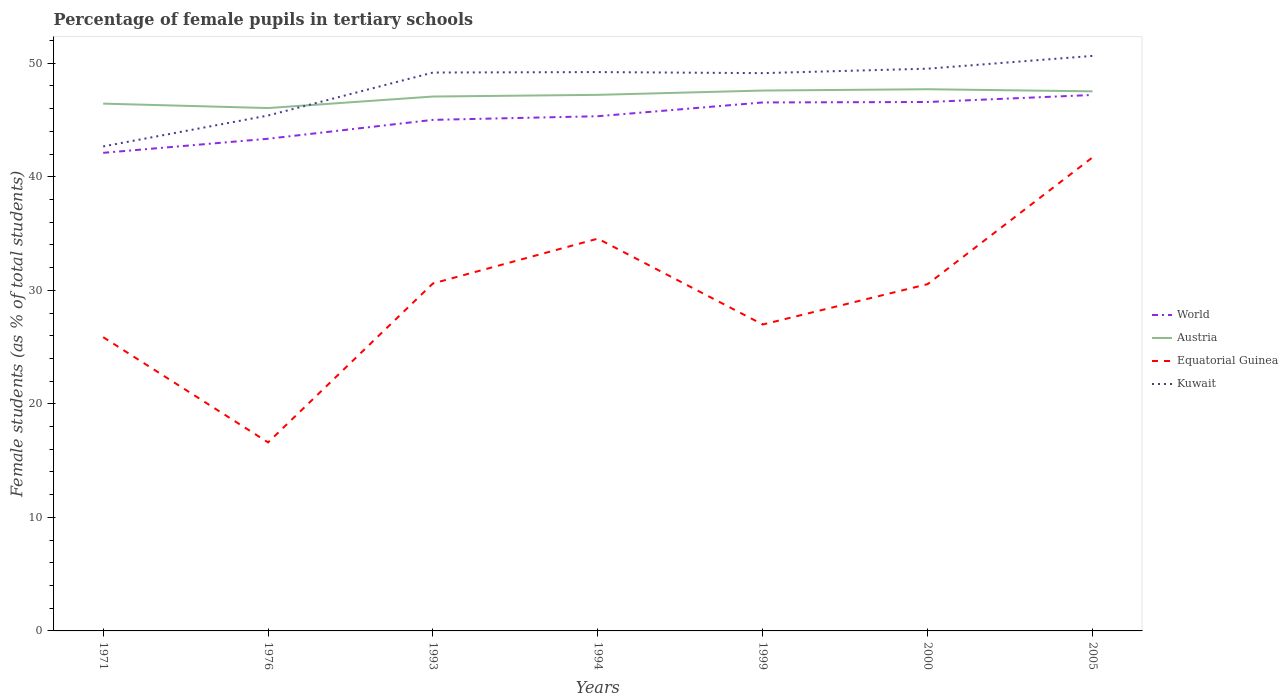Does the line corresponding to Kuwait intersect with the line corresponding to Equatorial Guinea?
Keep it short and to the point. No. Across all years, what is the maximum percentage of female pupils in tertiary schools in World?
Provide a succinct answer. 42.11. In which year was the percentage of female pupils in tertiary schools in Kuwait maximum?
Your answer should be very brief. 1971. What is the total percentage of female pupils in tertiary schools in Kuwait in the graph?
Offer a terse response. -1.47. What is the difference between the highest and the second highest percentage of female pupils in tertiary schools in Kuwait?
Provide a short and direct response. 7.97. What is the difference between the highest and the lowest percentage of female pupils in tertiary schools in World?
Provide a short and direct response. 4. Is the percentage of female pupils in tertiary schools in Austria strictly greater than the percentage of female pupils in tertiary schools in Kuwait over the years?
Keep it short and to the point. No. How many lines are there?
Provide a short and direct response. 4. Are the values on the major ticks of Y-axis written in scientific E-notation?
Make the answer very short. No. Does the graph contain any zero values?
Your answer should be compact. No. Does the graph contain grids?
Ensure brevity in your answer.  No. Where does the legend appear in the graph?
Your response must be concise. Center right. How many legend labels are there?
Provide a succinct answer. 4. What is the title of the graph?
Your answer should be compact. Percentage of female pupils in tertiary schools. Does "Mexico" appear as one of the legend labels in the graph?
Give a very brief answer. No. What is the label or title of the Y-axis?
Give a very brief answer. Female students (as % of total students). What is the Female students (as % of total students) in World in 1971?
Provide a succinct answer. 42.11. What is the Female students (as % of total students) of Austria in 1971?
Provide a short and direct response. 46.44. What is the Female students (as % of total students) of Equatorial Guinea in 1971?
Make the answer very short. 25.87. What is the Female students (as % of total students) of Kuwait in 1971?
Your answer should be compact. 42.67. What is the Female students (as % of total students) of World in 1976?
Ensure brevity in your answer.  43.35. What is the Female students (as % of total students) of Austria in 1976?
Give a very brief answer. 46.05. What is the Female students (as % of total students) in Equatorial Guinea in 1976?
Your answer should be compact. 16.6. What is the Female students (as % of total students) of Kuwait in 1976?
Keep it short and to the point. 45.4. What is the Female students (as % of total students) of World in 1993?
Your response must be concise. 45.01. What is the Female students (as % of total students) of Austria in 1993?
Provide a short and direct response. 47.07. What is the Female students (as % of total students) in Equatorial Guinea in 1993?
Provide a short and direct response. 30.61. What is the Female students (as % of total students) in Kuwait in 1993?
Provide a short and direct response. 49.18. What is the Female students (as % of total students) of World in 1994?
Offer a very short reply. 45.33. What is the Female students (as % of total students) of Austria in 1994?
Provide a short and direct response. 47.22. What is the Female students (as % of total students) of Equatorial Guinea in 1994?
Your answer should be very brief. 34.55. What is the Female students (as % of total students) of Kuwait in 1994?
Provide a succinct answer. 49.22. What is the Female students (as % of total students) of World in 1999?
Offer a terse response. 46.55. What is the Female students (as % of total students) in Austria in 1999?
Ensure brevity in your answer.  47.59. What is the Female students (as % of total students) in Equatorial Guinea in 1999?
Provide a succinct answer. 26.99. What is the Female students (as % of total students) in Kuwait in 1999?
Ensure brevity in your answer.  49.13. What is the Female students (as % of total students) in World in 2000?
Your response must be concise. 46.59. What is the Female students (as % of total students) of Austria in 2000?
Keep it short and to the point. 47.71. What is the Female students (as % of total students) of Equatorial Guinea in 2000?
Your answer should be very brief. 30.54. What is the Female students (as % of total students) of Kuwait in 2000?
Give a very brief answer. 49.52. What is the Female students (as % of total students) in World in 2005?
Offer a terse response. 47.21. What is the Female students (as % of total students) in Austria in 2005?
Make the answer very short. 47.53. What is the Female students (as % of total students) in Equatorial Guinea in 2005?
Keep it short and to the point. 41.71. What is the Female students (as % of total students) in Kuwait in 2005?
Offer a very short reply. 50.65. Across all years, what is the maximum Female students (as % of total students) in World?
Give a very brief answer. 47.21. Across all years, what is the maximum Female students (as % of total students) in Austria?
Offer a very short reply. 47.71. Across all years, what is the maximum Female students (as % of total students) in Equatorial Guinea?
Offer a very short reply. 41.71. Across all years, what is the maximum Female students (as % of total students) of Kuwait?
Keep it short and to the point. 50.65. Across all years, what is the minimum Female students (as % of total students) of World?
Give a very brief answer. 42.11. Across all years, what is the minimum Female students (as % of total students) of Austria?
Your answer should be compact. 46.05. Across all years, what is the minimum Female students (as % of total students) of Equatorial Guinea?
Provide a short and direct response. 16.6. Across all years, what is the minimum Female students (as % of total students) of Kuwait?
Make the answer very short. 42.67. What is the total Female students (as % of total students) in World in the graph?
Your answer should be very brief. 316.14. What is the total Female students (as % of total students) in Austria in the graph?
Ensure brevity in your answer.  329.61. What is the total Female students (as % of total students) of Equatorial Guinea in the graph?
Make the answer very short. 206.88. What is the total Female students (as % of total students) in Kuwait in the graph?
Give a very brief answer. 335.77. What is the difference between the Female students (as % of total students) in World in 1971 and that in 1976?
Make the answer very short. -1.24. What is the difference between the Female students (as % of total students) in Austria in 1971 and that in 1976?
Your answer should be very brief. 0.39. What is the difference between the Female students (as % of total students) of Equatorial Guinea in 1971 and that in 1976?
Give a very brief answer. 9.27. What is the difference between the Female students (as % of total students) of Kuwait in 1971 and that in 1976?
Keep it short and to the point. -2.72. What is the difference between the Female students (as % of total students) in World in 1971 and that in 1993?
Offer a very short reply. -2.9. What is the difference between the Female students (as % of total students) in Austria in 1971 and that in 1993?
Make the answer very short. -0.63. What is the difference between the Female students (as % of total students) in Equatorial Guinea in 1971 and that in 1993?
Ensure brevity in your answer.  -4.73. What is the difference between the Female students (as % of total students) of Kuwait in 1971 and that in 1993?
Offer a very short reply. -6.51. What is the difference between the Female students (as % of total students) in World in 1971 and that in 1994?
Give a very brief answer. -3.22. What is the difference between the Female students (as % of total students) of Austria in 1971 and that in 1994?
Give a very brief answer. -0.77. What is the difference between the Female students (as % of total students) in Equatorial Guinea in 1971 and that in 1994?
Your response must be concise. -8.68. What is the difference between the Female students (as % of total students) of Kuwait in 1971 and that in 1994?
Offer a terse response. -6.55. What is the difference between the Female students (as % of total students) in World in 1971 and that in 1999?
Make the answer very short. -4.44. What is the difference between the Female students (as % of total students) in Austria in 1971 and that in 1999?
Offer a terse response. -1.15. What is the difference between the Female students (as % of total students) in Equatorial Guinea in 1971 and that in 1999?
Provide a succinct answer. -1.12. What is the difference between the Female students (as % of total students) in Kuwait in 1971 and that in 1999?
Provide a succinct answer. -6.46. What is the difference between the Female students (as % of total students) in World in 1971 and that in 2000?
Give a very brief answer. -4.48. What is the difference between the Female students (as % of total students) in Austria in 1971 and that in 2000?
Give a very brief answer. -1.27. What is the difference between the Female students (as % of total students) of Equatorial Guinea in 1971 and that in 2000?
Offer a terse response. -4.67. What is the difference between the Female students (as % of total students) of Kuwait in 1971 and that in 2000?
Keep it short and to the point. -6.85. What is the difference between the Female students (as % of total students) of World in 1971 and that in 2005?
Give a very brief answer. -5.1. What is the difference between the Female students (as % of total students) in Austria in 1971 and that in 2005?
Keep it short and to the point. -1.08. What is the difference between the Female students (as % of total students) of Equatorial Guinea in 1971 and that in 2005?
Your response must be concise. -15.84. What is the difference between the Female students (as % of total students) in Kuwait in 1971 and that in 2005?
Give a very brief answer. -7.97. What is the difference between the Female students (as % of total students) of World in 1976 and that in 1993?
Provide a short and direct response. -1.66. What is the difference between the Female students (as % of total students) in Austria in 1976 and that in 1993?
Offer a very short reply. -1.02. What is the difference between the Female students (as % of total students) of Equatorial Guinea in 1976 and that in 1993?
Give a very brief answer. -14. What is the difference between the Female students (as % of total students) in Kuwait in 1976 and that in 1993?
Provide a succinct answer. -3.79. What is the difference between the Female students (as % of total students) in World in 1976 and that in 1994?
Make the answer very short. -1.98. What is the difference between the Female students (as % of total students) of Austria in 1976 and that in 1994?
Provide a succinct answer. -1.16. What is the difference between the Female students (as % of total students) in Equatorial Guinea in 1976 and that in 1994?
Your response must be concise. -17.95. What is the difference between the Female students (as % of total students) of Kuwait in 1976 and that in 1994?
Keep it short and to the point. -3.83. What is the difference between the Female students (as % of total students) of World in 1976 and that in 1999?
Ensure brevity in your answer.  -3.2. What is the difference between the Female students (as % of total students) of Austria in 1976 and that in 1999?
Offer a terse response. -1.54. What is the difference between the Female students (as % of total students) in Equatorial Guinea in 1976 and that in 1999?
Provide a short and direct response. -10.39. What is the difference between the Female students (as % of total students) in Kuwait in 1976 and that in 1999?
Ensure brevity in your answer.  -3.73. What is the difference between the Female students (as % of total students) in World in 1976 and that in 2000?
Provide a succinct answer. -3.24. What is the difference between the Female students (as % of total students) in Austria in 1976 and that in 2000?
Give a very brief answer. -1.66. What is the difference between the Female students (as % of total students) in Equatorial Guinea in 1976 and that in 2000?
Your answer should be compact. -13.94. What is the difference between the Female students (as % of total students) in Kuwait in 1976 and that in 2000?
Provide a short and direct response. -4.13. What is the difference between the Female students (as % of total students) of World in 1976 and that in 2005?
Ensure brevity in your answer.  -3.86. What is the difference between the Female students (as % of total students) in Austria in 1976 and that in 2005?
Give a very brief answer. -1.47. What is the difference between the Female students (as % of total students) in Equatorial Guinea in 1976 and that in 2005?
Provide a short and direct response. -25.1. What is the difference between the Female students (as % of total students) of Kuwait in 1976 and that in 2005?
Keep it short and to the point. -5.25. What is the difference between the Female students (as % of total students) of World in 1993 and that in 1994?
Your answer should be very brief. -0.32. What is the difference between the Female students (as % of total students) in Austria in 1993 and that in 1994?
Provide a succinct answer. -0.15. What is the difference between the Female students (as % of total students) in Equatorial Guinea in 1993 and that in 1994?
Give a very brief answer. -3.94. What is the difference between the Female students (as % of total students) in Kuwait in 1993 and that in 1994?
Offer a terse response. -0.04. What is the difference between the Female students (as % of total students) in World in 1993 and that in 1999?
Offer a terse response. -1.53. What is the difference between the Female students (as % of total students) in Austria in 1993 and that in 1999?
Ensure brevity in your answer.  -0.53. What is the difference between the Female students (as % of total students) of Equatorial Guinea in 1993 and that in 1999?
Make the answer very short. 3.62. What is the difference between the Female students (as % of total students) in Kuwait in 1993 and that in 1999?
Make the answer very short. 0.05. What is the difference between the Female students (as % of total students) in World in 1993 and that in 2000?
Offer a very short reply. -1.57. What is the difference between the Female students (as % of total students) of Austria in 1993 and that in 2000?
Your answer should be compact. -0.64. What is the difference between the Female students (as % of total students) in Equatorial Guinea in 1993 and that in 2000?
Your response must be concise. 0.06. What is the difference between the Female students (as % of total students) of Kuwait in 1993 and that in 2000?
Keep it short and to the point. -0.34. What is the difference between the Female students (as % of total students) of World in 1993 and that in 2005?
Offer a terse response. -2.19. What is the difference between the Female students (as % of total students) of Austria in 1993 and that in 2005?
Provide a short and direct response. -0.46. What is the difference between the Female students (as % of total students) of Equatorial Guinea in 1993 and that in 2005?
Keep it short and to the point. -11.1. What is the difference between the Female students (as % of total students) in Kuwait in 1993 and that in 2005?
Keep it short and to the point. -1.47. What is the difference between the Female students (as % of total students) in World in 1994 and that in 1999?
Offer a terse response. -1.21. What is the difference between the Female students (as % of total students) in Austria in 1994 and that in 1999?
Keep it short and to the point. -0.38. What is the difference between the Female students (as % of total students) of Equatorial Guinea in 1994 and that in 1999?
Keep it short and to the point. 7.56. What is the difference between the Female students (as % of total students) in Kuwait in 1994 and that in 1999?
Your answer should be very brief. 0.09. What is the difference between the Female students (as % of total students) of World in 1994 and that in 2000?
Offer a terse response. -1.25. What is the difference between the Female students (as % of total students) in Austria in 1994 and that in 2000?
Ensure brevity in your answer.  -0.49. What is the difference between the Female students (as % of total students) in Equatorial Guinea in 1994 and that in 2000?
Your answer should be compact. 4.01. What is the difference between the Female students (as % of total students) in Kuwait in 1994 and that in 2000?
Offer a terse response. -0.3. What is the difference between the Female students (as % of total students) in World in 1994 and that in 2005?
Your answer should be very brief. -1.87. What is the difference between the Female students (as % of total students) of Austria in 1994 and that in 2005?
Your answer should be very brief. -0.31. What is the difference between the Female students (as % of total students) of Equatorial Guinea in 1994 and that in 2005?
Ensure brevity in your answer.  -7.16. What is the difference between the Female students (as % of total students) in Kuwait in 1994 and that in 2005?
Ensure brevity in your answer.  -1.43. What is the difference between the Female students (as % of total students) in World in 1999 and that in 2000?
Offer a terse response. -0.04. What is the difference between the Female students (as % of total students) in Austria in 1999 and that in 2000?
Your response must be concise. -0.12. What is the difference between the Female students (as % of total students) of Equatorial Guinea in 1999 and that in 2000?
Make the answer very short. -3.55. What is the difference between the Female students (as % of total students) in Kuwait in 1999 and that in 2000?
Provide a short and direct response. -0.39. What is the difference between the Female students (as % of total students) in World in 1999 and that in 2005?
Give a very brief answer. -0.66. What is the difference between the Female students (as % of total students) of Austria in 1999 and that in 2005?
Your response must be concise. 0.07. What is the difference between the Female students (as % of total students) in Equatorial Guinea in 1999 and that in 2005?
Your response must be concise. -14.72. What is the difference between the Female students (as % of total students) of Kuwait in 1999 and that in 2005?
Your response must be concise. -1.52. What is the difference between the Female students (as % of total students) in World in 2000 and that in 2005?
Provide a short and direct response. -0.62. What is the difference between the Female students (as % of total students) in Austria in 2000 and that in 2005?
Keep it short and to the point. 0.19. What is the difference between the Female students (as % of total students) of Equatorial Guinea in 2000 and that in 2005?
Ensure brevity in your answer.  -11.17. What is the difference between the Female students (as % of total students) in Kuwait in 2000 and that in 2005?
Offer a very short reply. -1.13. What is the difference between the Female students (as % of total students) in World in 1971 and the Female students (as % of total students) in Austria in 1976?
Provide a short and direct response. -3.94. What is the difference between the Female students (as % of total students) in World in 1971 and the Female students (as % of total students) in Equatorial Guinea in 1976?
Offer a very short reply. 25.51. What is the difference between the Female students (as % of total students) of World in 1971 and the Female students (as % of total students) of Kuwait in 1976?
Your answer should be very brief. -3.29. What is the difference between the Female students (as % of total students) of Austria in 1971 and the Female students (as % of total students) of Equatorial Guinea in 1976?
Your answer should be very brief. 29.84. What is the difference between the Female students (as % of total students) of Austria in 1971 and the Female students (as % of total students) of Kuwait in 1976?
Offer a very short reply. 1.05. What is the difference between the Female students (as % of total students) of Equatorial Guinea in 1971 and the Female students (as % of total students) of Kuwait in 1976?
Ensure brevity in your answer.  -19.52. What is the difference between the Female students (as % of total students) of World in 1971 and the Female students (as % of total students) of Austria in 1993?
Ensure brevity in your answer.  -4.96. What is the difference between the Female students (as % of total students) of World in 1971 and the Female students (as % of total students) of Equatorial Guinea in 1993?
Your answer should be very brief. 11.5. What is the difference between the Female students (as % of total students) in World in 1971 and the Female students (as % of total students) in Kuwait in 1993?
Make the answer very short. -7.07. What is the difference between the Female students (as % of total students) of Austria in 1971 and the Female students (as % of total students) of Equatorial Guinea in 1993?
Offer a very short reply. 15.84. What is the difference between the Female students (as % of total students) of Austria in 1971 and the Female students (as % of total students) of Kuwait in 1993?
Offer a terse response. -2.74. What is the difference between the Female students (as % of total students) of Equatorial Guinea in 1971 and the Female students (as % of total students) of Kuwait in 1993?
Your answer should be compact. -23.31. What is the difference between the Female students (as % of total students) in World in 1971 and the Female students (as % of total students) in Austria in 1994?
Ensure brevity in your answer.  -5.11. What is the difference between the Female students (as % of total students) of World in 1971 and the Female students (as % of total students) of Equatorial Guinea in 1994?
Your answer should be compact. 7.56. What is the difference between the Female students (as % of total students) of World in 1971 and the Female students (as % of total students) of Kuwait in 1994?
Provide a short and direct response. -7.11. What is the difference between the Female students (as % of total students) in Austria in 1971 and the Female students (as % of total students) in Equatorial Guinea in 1994?
Offer a terse response. 11.89. What is the difference between the Female students (as % of total students) in Austria in 1971 and the Female students (as % of total students) in Kuwait in 1994?
Offer a very short reply. -2.78. What is the difference between the Female students (as % of total students) in Equatorial Guinea in 1971 and the Female students (as % of total students) in Kuwait in 1994?
Keep it short and to the point. -23.35. What is the difference between the Female students (as % of total students) of World in 1971 and the Female students (as % of total students) of Austria in 1999?
Make the answer very short. -5.49. What is the difference between the Female students (as % of total students) in World in 1971 and the Female students (as % of total students) in Equatorial Guinea in 1999?
Your response must be concise. 15.12. What is the difference between the Female students (as % of total students) of World in 1971 and the Female students (as % of total students) of Kuwait in 1999?
Give a very brief answer. -7.02. What is the difference between the Female students (as % of total students) in Austria in 1971 and the Female students (as % of total students) in Equatorial Guinea in 1999?
Your answer should be compact. 19.45. What is the difference between the Female students (as % of total students) in Austria in 1971 and the Female students (as % of total students) in Kuwait in 1999?
Offer a terse response. -2.69. What is the difference between the Female students (as % of total students) in Equatorial Guinea in 1971 and the Female students (as % of total students) in Kuwait in 1999?
Your answer should be compact. -23.26. What is the difference between the Female students (as % of total students) in World in 1971 and the Female students (as % of total students) in Austria in 2000?
Your answer should be compact. -5.6. What is the difference between the Female students (as % of total students) in World in 1971 and the Female students (as % of total students) in Equatorial Guinea in 2000?
Provide a short and direct response. 11.57. What is the difference between the Female students (as % of total students) of World in 1971 and the Female students (as % of total students) of Kuwait in 2000?
Provide a short and direct response. -7.41. What is the difference between the Female students (as % of total students) of Austria in 1971 and the Female students (as % of total students) of Equatorial Guinea in 2000?
Your answer should be very brief. 15.9. What is the difference between the Female students (as % of total students) of Austria in 1971 and the Female students (as % of total students) of Kuwait in 2000?
Provide a short and direct response. -3.08. What is the difference between the Female students (as % of total students) of Equatorial Guinea in 1971 and the Female students (as % of total students) of Kuwait in 2000?
Provide a succinct answer. -23.65. What is the difference between the Female students (as % of total students) in World in 1971 and the Female students (as % of total students) in Austria in 2005?
Ensure brevity in your answer.  -5.42. What is the difference between the Female students (as % of total students) of World in 1971 and the Female students (as % of total students) of Equatorial Guinea in 2005?
Your answer should be compact. 0.4. What is the difference between the Female students (as % of total students) of World in 1971 and the Female students (as % of total students) of Kuwait in 2005?
Give a very brief answer. -8.54. What is the difference between the Female students (as % of total students) of Austria in 1971 and the Female students (as % of total students) of Equatorial Guinea in 2005?
Offer a very short reply. 4.74. What is the difference between the Female students (as % of total students) of Austria in 1971 and the Female students (as % of total students) of Kuwait in 2005?
Ensure brevity in your answer.  -4.2. What is the difference between the Female students (as % of total students) of Equatorial Guinea in 1971 and the Female students (as % of total students) of Kuwait in 2005?
Provide a short and direct response. -24.77. What is the difference between the Female students (as % of total students) of World in 1976 and the Female students (as % of total students) of Austria in 1993?
Make the answer very short. -3.72. What is the difference between the Female students (as % of total students) of World in 1976 and the Female students (as % of total students) of Equatorial Guinea in 1993?
Ensure brevity in your answer.  12.74. What is the difference between the Female students (as % of total students) of World in 1976 and the Female students (as % of total students) of Kuwait in 1993?
Offer a very short reply. -5.83. What is the difference between the Female students (as % of total students) of Austria in 1976 and the Female students (as % of total students) of Equatorial Guinea in 1993?
Offer a terse response. 15.45. What is the difference between the Female students (as % of total students) of Austria in 1976 and the Female students (as % of total students) of Kuwait in 1993?
Your response must be concise. -3.13. What is the difference between the Female students (as % of total students) in Equatorial Guinea in 1976 and the Female students (as % of total students) in Kuwait in 1993?
Your response must be concise. -32.58. What is the difference between the Female students (as % of total students) of World in 1976 and the Female students (as % of total students) of Austria in 1994?
Make the answer very short. -3.87. What is the difference between the Female students (as % of total students) of World in 1976 and the Female students (as % of total students) of Equatorial Guinea in 1994?
Offer a terse response. 8.8. What is the difference between the Female students (as % of total students) in World in 1976 and the Female students (as % of total students) in Kuwait in 1994?
Your answer should be very brief. -5.87. What is the difference between the Female students (as % of total students) of Austria in 1976 and the Female students (as % of total students) of Equatorial Guinea in 1994?
Offer a very short reply. 11.5. What is the difference between the Female students (as % of total students) in Austria in 1976 and the Female students (as % of total students) in Kuwait in 1994?
Give a very brief answer. -3.17. What is the difference between the Female students (as % of total students) in Equatorial Guinea in 1976 and the Female students (as % of total students) in Kuwait in 1994?
Offer a very short reply. -32.62. What is the difference between the Female students (as % of total students) of World in 1976 and the Female students (as % of total students) of Austria in 1999?
Provide a short and direct response. -4.25. What is the difference between the Female students (as % of total students) in World in 1976 and the Female students (as % of total students) in Equatorial Guinea in 1999?
Provide a succinct answer. 16.36. What is the difference between the Female students (as % of total students) in World in 1976 and the Female students (as % of total students) in Kuwait in 1999?
Your answer should be compact. -5.78. What is the difference between the Female students (as % of total students) in Austria in 1976 and the Female students (as % of total students) in Equatorial Guinea in 1999?
Offer a terse response. 19.06. What is the difference between the Female students (as % of total students) of Austria in 1976 and the Female students (as % of total students) of Kuwait in 1999?
Provide a succinct answer. -3.08. What is the difference between the Female students (as % of total students) in Equatorial Guinea in 1976 and the Female students (as % of total students) in Kuwait in 1999?
Give a very brief answer. -32.53. What is the difference between the Female students (as % of total students) in World in 1976 and the Female students (as % of total students) in Austria in 2000?
Your answer should be very brief. -4.36. What is the difference between the Female students (as % of total students) of World in 1976 and the Female students (as % of total students) of Equatorial Guinea in 2000?
Give a very brief answer. 12.81. What is the difference between the Female students (as % of total students) in World in 1976 and the Female students (as % of total students) in Kuwait in 2000?
Give a very brief answer. -6.17. What is the difference between the Female students (as % of total students) of Austria in 1976 and the Female students (as % of total students) of Equatorial Guinea in 2000?
Your answer should be very brief. 15.51. What is the difference between the Female students (as % of total students) of Austria in 1976 and the Female students (as % of total students) of Kuwait in 2000?
Ensure brevity in your answer.  -3.47. What is the difference between the Female students (as % of total students) of Equatorial Guinea in 1976 and the Female students (as % of total students) of Kuwait in 2000?
Offer a terse response. -32.92. What is the difference between the Female students (as % of total students) of World in 1976 and the Female students (as % of total students) of Austria in 2005?
Ensure brevity in your answer.  -4.18. What is the difference between the Female students (as % of total students) in World in 1976 and the Female students (as % of total students) in Equatorial Guinea in 2005?
Provide a short and direct response. 1.64. What is the difference between the Female students (as % of total students) in World in 1976 and the Female students (as % of total students) in Kuwait in 2005?
Your answer should be very brief. -7.3. What is the difference between the Female students (as % of total students) of Austria in 1976 and the Female students (as % of total students) of Equatorial Guinea in 2005?
Provide a short and direct response. 4.34. What is the difference between the Female students (as % of total students) in Austria in 1976 and the Female students (as % of total students) in Kuwait in 2005?
Provide a short and direct response. -4.59. What is the difference between the Female students (as % of total students) of Equatorial Guinea in 1976 and the Female students (as % of total students) of Kuwait in 2005?
Your response must be concise. -34.04. What is the difference between the Female students (as % of total students) of World in 1993 and the Female students (as % of total students) of Austria in 1994?
Your response must be concise. -2.2. What is the difference between the Female students (as % of total students) in World in 1993 and the Female students (as % of total students) in Equatorial Guinea in 1994?
Your response must be concise. 10.46. What is the difference between the Female students (as % of total students) of World in 1993 and the Female students (as % of total students) of Kuwait in 1994?
Keep it short and to the point. -4.21. What is the difference between the Female students (as % of total students) in Austria in 1993 and the Female students (as % of total students) in Equatorial Guinea in 1994?
Offer a very short reply. 12.52. What is the difference between the Female students (as % of total students) of Austria in 1993 and the Female students (as % of total students) of Kuwait in 1994?
Your answer should be very brief. -2.15. What is the difference between the Female students (as % of total students) in Equatorial Guinea in 1993 and the Female students (as % of total students) in Kuwait in 1994?
Your answer should be very brief. -18.61. What is the difference between the Female students (as % of total students) of World in 1993 and the Female students (as % of total students) of Austria in 1999?
Keep it short and to the point. -2.58. What is the difference between the Female students (as % of total students) in World in 1993 and the Female students (as % of total students) in Equatorial Guinea in 1999?
Your response must be concise. 18.02. What is the difference between the Female students (as % of total students) in World in 1993 and the Female students (as % of total students) in Kuwait in 1999?
Give a very brief answer. -4.12. What is the difference between the Female students (as % of total students) of Austria in 1993 and the Female students (as % of total students) of Equatorial Guinea in 1999?
Offer a very short reply. 20.08. What is the difference between the Female students (as % of total students) in Austria in 1993 and the Female students (as % of total students) in Kuwait in 1999?
Ensure brevity in your answer.  -2.06. What is the difference between the Female students (as % of total students) of Equatorial Guinea in 1993 and the Female students (as % of total students) of Kuwait in 1999?
Keep it short and to the point. -18.52. What is the difference between the Female students (as % of total students) in World in 1993 and the Female students (as % of total students) in Austria in 2000?
Your response must be concise. -2.7. What is the difference between the Female students (as % of total students) in World in 1993 and the Female students (as % of total students) in Equatorial Guinea in 2000?
Provide a succinct answer. 14.47. What is the difference between the Female students (as % of total students) in World in 1993 and the Female students (as % of total students) in Kuwait in 2000?
Offer a very short reply. -4.51. What is the difference between the Female students (as % of total students) of Austria in 1993 and the Female students (as % of total students) of Equatorial Guinea in 2000?
Provide a short and direct response. 16.53. What is the difference between the Female students (as % of total students) of Austria in 1993 and the Female students (as % of total students) of Kuwait in 2000?
Keep it short and to the point. -2.45. What is the difference between the Female students (as % of total students) of Equatorial Guinea in 1993 and the Female students (as % of total students) of Kuwait in 2000?
Keep it short and to the point. -18.91. What is the difference between the Female students (as % of total students) in World in 1993 and the Female students (as % of total students) in Austria in 2005?
Your answer should be compact. -2.51. What is the difference between the Female students (as % of total students) in World in 1993 and the Female students (as % of total students) in Equatorial Guinea in 2005?
Make the answer very short. 3.31. What is the difference between the Female students (as % of total students) in World in 1993 and the Female students (as % of total students) in Kuwait in 2005?
Keep it short and to the point. -5.63. What is the difference between the Female students (as % of total students) of Austria in 1993 and the Female students (as % of total students) of Equatorial Guinea in 2005?
Make the answer very short. 5.36. What is the difference between the Female students (as % of total students) of Austria in 1993 and the Female students (as % of total students) of Kuwait in 2005?
Your answer should be compact. -3.58. What is the difference between the Female students (as % of total students) in Equatorial Guinea in 1993 and the Female students (as % of total students) in Kuwait in 2005?
Your answer should be compact. -20.04. What is the difference between the Female students (as % of total students) of World in 1994 and the Female students (as % of total students) of Austria in 1999?
Ensure brevity in your answer.  -2.26. What is the difference between the Female students (as % of total students) of World in 1994 and the Female students (as % of total students) of Equatorial Guinea in 1999?
Ensure brevity in your answer.  18.34. What is the difference between the Female students (as % of total students) of World in 1994 and the Female students (as % of total students) of Kuwait in 1999?
Your response must be concise. -3.8. What is the difference between the Female students (as % of total students) in Austria in 1994 and the Female students (as % of total students) in Equatorial Guinea in 1999?
Provide a succinct answer. 20.23. What is the difference between the Female students (as % of total students) in Austria in 1994 and the Female students (as % of total students) in Kuwait in 1999?
Your response must be concise. -1.91. What is the difference between the Female students (as % of total students) in Equatorial Guinea in 1994 and the Female students (as % of total students) in Kuwait in 1999?
Offer a very short reply. -14.58. What is the difference between the Female students (as % of total students) in World in 1994 and the Female students (as % of total students) in Austria in 2000?
Make the answer very short. -2.38. What is the difference between the Female students (as % of total students) of World in 1994 and the Female students (as % of total students) of Equatorial Guinea in 2000?
Your answer should be compact. 14.79. What is the difference between the Female students (as % of total students) of World in 1994 and the Female students (as % of total students) of Kuwait in 2000?
Your response must be concise. -4.19. What is the difference between the Female students (as % of total students) in Austria in 1994 and the Female students (as % of total students) in Equatorial Guinea in 2000?
Keep it short and to the point. 16.67. What is the difference between the Female students (as % of total students) in Austria in 1994 and the Female students (as % of total students) in Kuwait in 2000?
Your answer should be very brief. -2.3. What is the difference between the Female students (as % of total students) in Equatorial Guinea in 1994 and the Female students (as % of total students) in Kuwait in 2000?
Your answer should be very brief. -14.97. What is the difference between the Female students (as % of total students) of World in 1994 and the Female students (as % of total students) of Austria in 2005?
Provide a succinct answer. -2.19. What is the difference between the Female students (as % of total students) in World in 1994 and the Female students (as % of total students) in Equatorial Guinea in 2005?
Your response must be concise. 3.63. What is the difference between the Female students (as % of total students) of World in 1994 and the Female students (as % of total students) of Kuwait in 2005?
Offer a terse response. -5.31. What is the difference between the Female students (as % of total students) of Austria in 1994 and the Female students (as % of total students) of Equatorial Guinea in 2005?
Make the answer very short. 5.51. What is the difference between the Female students (as % of total students) in Austria in 1994 and the Female students (as % of total students) in Kuwait in 2005?
Provide a succinct answer. -3.43. What is the difference between the Female students (as % of total students) in Equatorial Guinea in 1994 and the Female students (as % of total students) in Kuwait in 2005?
Your response must be concise. -16.1. What is the difference between the Female students (as % of total students) in World in 1999 and the Female students (as % of total students) in Austria in 2000?
Make the answer very short. -1.16. What is the difference between the Female students (as % of total students) of World in 1999 and the Female students (as % of total students) of Equatorial Guinea in 2000?
Your answer should be very brief. 16. What is the difference between the Female students (as % of total students) of World in 1999 and the Female students (as % of total students) of Kuwait in 2000?
Provide a succinct answer. -2.97. What is the difference between the Female students (as % of total students) in Austria in 1999 and the Female students (as % of total students) in Equatorial Guinea in 2000?
Provide a short and direct response. 17.05. What is the difference between the Female students (as % of total students) in Austria in 1999 and the Female students (as % of total students) in Kuwait in 2000?
Provide a succinct answer. -1.93. What is the difference between the Female students (as % of total students) in Equatorial Guinea in 1999 and the Female students (as % of total students) in Kuwait in 2000?
Provide a succinct answer. -22.53. What is the difference between the Female students (as % of total students) in World in 1999 and the Female students (as % of total students) in Austria in 2005?
Give a very brief answer. -0.98. What is the difference between the Female students (as % of total students) of World in 1999 and the Female students (as % of total students) of Equatorial Guinea in 2005?
Provide a succinct answer. 4.84. What is the difference between the Female students (as % of total students) of World in 1999 and the Female students (as % of total students) of Kuwait in 2005?
Provide a succinct answer. -4.1. What is the difference between the Female students (as % of total students) of Austria in 1999 and the Female students (as % of total students) of Equatorial Guinea in 2005?
Give a very brief answer. 5.89. What is the difference between the Female students (as % of total students) in Austria in 1999 and the Female students (as % of total students) in Kuwait in 2005?
Keep it short and to the point. -3.05. What is the difference between the Female students (as % of total students) in Equatorial Guinea in 1999 and the Female students (as % of total students) in Kuwait in 2005?
Your answer should be compact. -23.66. What is the difference between the Female students (as % of total students) in World in 2000 and the Female students (as % of total students) in Austria in 2005?
Provide a succinct answer. -0.94. What is the difference between the Female students (as % of total students) in World in 2000 and the Female students (as % of total students) in Equatorial Guinea in 2005?
Offer a very short reply. 4.88. What is the difference between the Female students (as % of total students) in World in 2000 and the Female students (as % of total students) in Kuwait in 2005?
Provide a short and direct response. -4.06. What is the difference between the Female students (as % of total students) of Austria in 2000 and the Female students (as % of total students) of Equatorial Guinea in 2005?
Ensure brevity in your answer.  6. What is the difference between the Female students (as % of total students) in Austria in 2000 and the Female students (as % of total students) in Kuwait in 2005?
Offer a very short reply. -2.94. What is the difference between the Female students (as % of total students) of Equatorial Guinea in 2000 and the Female students (as % of total students) of Kuwait in 2005?
Provide a short and direct response. -20.1. What is the average Female students (as % of total students) of World per year?
Ensure brevity in your answer.  45.16. What is the average Female students (as % of total students) in Austria per year?
Make the answer very short. 47.09. What is the average Female students (as % of total students) in Equatorial Guinea per year?
Provide a short and direct response. 29.55. What is the average Female students (as % of total students) in Kuwait per year?
Keep it short and to the point. 47.97. In the year 1971, what is the difference between the Female students (as % of total students) of World and Female students (as % of total students) of Austria?
Offer a very short reply. -4.33. In the year 1971, what is the difference between the Female students (as % of total students) of World and Female students (as % of total students) of Equatorial Guinea?
Offer a very short reply. 16.24. In the year 1971, what is the difference between the Female students (as % of total students) of World and Female students (as % of total students) of Kuwait?
Provide a short and direct response. -0.56. In the year 1971, what is the difference between the Female students (as % of total students) of Austria and Female students (as % of total students) of Equatorial Guinea?
Make the answer very short. 20.57. In the year 1971, what is the difference between the Female students (as % of total students) in Austria and Female students (as % of total students) in Kuwait?
Your answer should be compact. 3.77. In the year 1971, what is the difference between the Female students (as % of total students) of Equatorial Guinea and Female students (as % of total students) of Kuwait?
Your response must be concise. -16.8. In the year 1976, what is the difference between the Female students (as % of total students) of World and Female students (as % of total students) of Austria?
Ensure brevity in your answer.  -2.7. In the year 1976, what is the difference between the Female students (as % of total students) of World and Female students (as % of total students) of Equatorial Guinea?
Provide a succinct answer. 26.75. In the year 1976, what is the difference between the Female students (as % of total students) in World and Female students (as % of total students) in Kuwait?
Your response must be concise. -2.05. In the year 1976, what is the difference between the Female students (as % of total students) of Austria and Female students (as % of total students) of Equatorial Guinea?
Offer a very short reply. 29.45. In the year 1976, what is the difference between the Female students (as % of total students) in Austria and Female students (as % of total students) in Kuwait?
Keep it short and to the point. 0.66. In the year 1976, what is the difference between the Female students (as % of total students) in Equatorial Guinea and Female students (as % of total students) in Kuwait?
Your answer should be very brief. -28.79. In the year 1993, what is the difference between the Female students (as % of total students) of World and Female students (as % of total students) of Austria?
Give a very brief answer. -2.06. In the year 1993, what is the difference between the Female students (as % of total students) in World and Female students (as % of total students) in Equatorial Guinea?
Give a very brief answer. 14.41. In the year 1993, what is the difference between the Female students (as % of total students) of World and Female students (as % of total students) of Kuwait?
Make the answer very short. -4.17. In the year 1993, what is the difference between the Female students (as % of total students) in Austria and Female students (as % of total students) in Equatorial Guinea?
Provide a short and direct response. 16.46. In the year 1993, what is the difference between the Female students (as % of total students) of Austria and Female students (as % of total students) of Kuwait?
Your response must be concise. -2.11. In the year 1993, what is the difference between the Female students (as % of total students) in Equatorial Guinea and Female students (as % of total students) in Kuwait?
Keep it short and to the point. -18.57. In the year 1994, what is the difference between the Female students (as % of total students) in World and Female students (as % of total students) in Austria?
Offer a terse response. -1.88. In the year 1994, what is the difference between the Female students (as % of total students) of World and Female students (as % of total students) of Equatorial Guinea?
Offer a very short reply. 10.78. In the year 1994, what is the difference between the Female students (as % of total students) of World and Female students (as % of total students) of Kuwait?
Offer a terse response. -3.89. In the year 1994, what is the difference between the Female students (as % of total students) of Austria and Female students (as % of total students) of Equatorial Guinea?
Offer a terse response. 12.67. In the year 1994, what is the difference between the Female students (as % of total students) of Austria and Female students (as % of total students) of Kuwait?
Provide a succinct answer. -2. In the year 1994, what is the difference between the Female students (as % of total students) of Equatorial Guinea and Female students (as % of total students) of Kuwait?
Offer a terse response. -14.67. In the year 1999, what is the difference between the Female students (as % of total students) of World and Female students (as % of total students) of Austria?
Provide a succinct answer. -1.05. In the year 1999, what is the difference between the Female students (as % of total students) in World and Female students (as % of total students) in Equatorial Guinea?
Keep it short and to the point. 19.56. In the year 1999, what is the difference between the Female students (as % of total students) of World and Female students (as % of total students) of Kuwait?
Offer a terse response. -2.58. In the year 1999, what is the difference between the Female students (as % of total students) in Austria and Female students (as % of total students) in Equatorial Guinea?
Ensure brevity in your answer.  20.61. In the year 1999, what is the difference between the Female students (as % of total students) in Austria and Female students (as % of total students) in Kuwait?
Make the answer very short. -1.53. In the year 1999, what is the difference between the Female students (as % of total students) of Equatorial Guinea and Female students (as % of total students) of Kuwait?
Provide a succinct answer. -22.14. In the year 2000, what is the difference between the Female students (as % of total students) in World and Female students (as % of total students) in Austria?
Keep it short and to the point. -1.13. In the year 2000, what is the difference between the Female students (as % of total students) of World and Female students (as % of total students) of Equatorial Guinea?
Ensure brevity in your answer.  16.04. In the year 2000, what is the difference between the Female students (as % of total students) of World and Female students (as % of total students) of Kuwait?
Make the answer very short. -2.94. In the year 2000, what is the difference between the Female students (as % of total students) in Austria and Female students (as % of total students) in Equatorial Guinea?
Provide a succinct answer. 17.17. In the year 2000, what is the difference between the Female students (as % of total students) in Austria and Female students (as % of total students) in Kuwait?
Offer a very short reply. -1.81. In the year 2000, what is the difference between the Female students (as % of total students) of Equatorial Guinea and Female students (as % of total students) of Kuwait?
Give a very brief answer. -18.98. In the year 2005, what is the difference between the Female students (as % of total students) of World and Female students (as % of total students) of Austria?
Keep it short and to the point. -0.32. In the year 2005, what is the difference between the Female students (as % of total students) of World and Female students (as % of total students) of Equatorial Guinea?
Ensure brevity in your answer.  5.5. In the year 2005, what is the difference between the Female students (as % of total students) of World and Female students (as % of total students) of Kuwait?
Your response must be concise. -3.44. In the year 2005, what is the difference between the Female students (as % of total students) in Austria and Female students (as % of total students) in Equatorial Guinea?
Ensure brevity in your answer.  5.82. In the year 2005, what is the difference between the Female students (as % of total students) of Austria and Female students (as % of total students) of Kuwait?
Provide a short and direct response. -3.12. In the year 2005, what is the difference between the Female students (as % of total students) in Equatorial Guinea and Female students (as % of total students) in Kuwait?
Provide a short and direct response. -8.94. What is the ratio of the Female students (as % of total students) of World in 1971 to that in 1976?
Keep it short and to the point. 0.97. What is the ratio of the Female students (as % of total students) of Austria in 1971 to that in 1976?
Ensure brevity in your answer.  1.01. What is the ratio of the Female students (as % of total students) of Equatorial Guinea in 1971 to that in 1976?
Ensure brevity in your answer.  1.56. What is the ratio of the Female students (as % of total students) of Kuwait in 1971 to that in 1976?
Your answer should be compact. 0.94. What is the ratio of the Female students (as % of total students) of World in 1971 to that in 1993?
Ensure brevity in your answer.  0.94. What is the ratio of the Female students (as % of total students) of Austria in 1971 to that in 1993?
Make the answer very short. 0.99. What is the ratio of the Female students (as % of total students) in Equatorial Guinea in 1971 to that in 1993?
Make the answer very short. 0.85. What is the ratio of the Female students (as % of total students) in Kuwait in 1971 to that in 1993?
Keep it short and to the point. 0.87. What is the ratio of the Female students (as % of total students) in World in 1971 to that in 1994?
Ensure brevity in your answer.  0.93. What is the ratio of the Female students (as % of total students) of Austria in 1971 to that in 1994?
Offer a very short reply. 0.98. What is the ratio of the Female students (as % of total students) of Equatorial Guinea in 1971 to that in 1994?
Offer a very short reply. 0.75. What is the ratio of the Female students (as % of total students) in Kuwait in 1971 to that in 1994?
Offer a terse response. 0.87. What is the ratio of the Female students (as % of total students) in World in 1971 to that in 1999?
Offer a very short reply. 0.9. What is the ratio of the Female students (as % of total students) in Austria in 1971 to that in 1999?
Your answer should be very brief. 0.98. What is the ratio of the Female students (as % of total students) in Equatorial Guinea in 1971 to that in 1999?
Ensure brevity in your answer.  0.96. What is the ratio of the Female students (as % of total students) of Kuwait in 1971 to that in 1999?
Keep it short and to the point. 0.87. What is the ratio of the Female students (as % of total students) of World in 1971 to that in 2000?
Your response must be concise. 0.9. What is the ratio of the Female students (as % of total students) in Austria in 1971 to that in 2000?
Make the answer very short. 0.97. What is the ratio of the Female students (as % of total students) of Equatorial Guinea in 1971 to that in 2000?
Provide a succinct answer. 0.85. What is the ratio of the Female students (as % of total students) in Kuwait in 1971 to that in 2000?
Provide a succinct answer. 0.86. What is the ratio of the Female students (as % of total students) of World in 1971 to that in 2005?
Your answer should be very brief. 0.89. What is the ratio of the Female students (as % of total students) in Austria in 1971 to that in 2005?
Your answer should be compact. 0.98. What is the ratio of the Female students (as % of total students) in Equatorial Guinea in 1971 to that in 2005?
Make the answer very short. 0.62. What is the ratio of the Female students (as % of total students) in Kuwait in 1971 to that in 2005?
Ensure brevity in your answer.  0.84. What is the ratio of the Female students (as % of total students) in Austria in 1976 to that in 1993?
Offer a terse response. 0.98. What is the ratio of the Female students (as % of total students) in Equatorial Guinea in 1976 to that in 1993?
Provide a short and direct response. 0.54. What is the ratio of the Female students (as % of total students) of Kuwait in 1976 to that in 1993?
Your answer should be very brief. 0.92. What is the ratio of the Female students (as % of total students) of World in 1976 to that in 1994?
Provide a succinct answer. 0.96. What is the ratio of the Female students (as % of total students) in Austria in 1976 to that in 1994?
Provide a short and direct response. 0.98. What is the ratio of the Female students (as % of total students) of Equatorial Guinea in 1976 to that in 1994?
Offer a very short reply. 0.48. What is the ratio of the Female students (as % of total students) of Kuwait in 1976 to that in 1994?
Offer a very short reply. 0.92. What is the ratio of the Female students (as % of total students) in World in 1976 to that in 1999?
Offer a terse response. 0.93. What is the ratio of the Female students (as % of total students) of Austria in 1976 to that in 1999?
Offer a terse response. 0.97. What is the ratio of the Female students (as % of total students) of Equatorial Guinea in 1976 to that in 1999?
Make the answer very short. 0.62. What is the ratio of the Female students (as % of total students) of Kuwait in 1976 to that in 1999?
Ensure brevity in your answer.  0.92. What is the ratio of the Female students (as % of total students) of World in 1976 to that in 2000?
Keep it short and to the point. 0.93. What is the ratio of the Female students (as % of total students) in Austria in 1976 to that in 2000?
Make the answer very short. 0.97. What is the ratio of the Female students (as % of total students) of Equatorial Guinea in 1976 to that in 2000?
Your answer should be compact. 0.54. What is the ratio of the Female students (as % of total students) in Kuwait in 1976 to that in 2000?
Provide a succinct answer. 0.92. What is the ratio of the Female students (as % of total students) in World in 1976 to that in 2005?
Your answer should be very brief. 0.92. What is the ratio of the Female students (as % of total students) in Equatorial Guinea in 1976 to that in 2005?
Your answer should be compact. 0.4. What is the ratio of the Female students (as % of total students) of Kuwait in 1976 to that in 2005?
Ensure brevity in your answer.  0.9. What is the ratio of the Female students (as % of total students) in World in 1993 to that in 1994?
Make the answer very short. 0.99. What is the ratio of the Female students (as % of total students) in Austria in 1993 to that in 1994?
Your response must be concise. 1. What is the ratio of the Female students (as % of total students) in Equatorial Guinea in 1993 to that in 1994?
Offer a very short reply. 0.89. What is the ratio of the Female students (as % of total students) of World in 1993 to that in 1999?
Give a very brief answer. 0.97. What is the ratio of the Female students (as % of total students) in Austria in 1993 to that in 1999?
Provide a short and direct response. 0.99. What is the ratio of the Female students (as % of total students) in Equatorial Guinea in 1993 to that in 1999?
Give a very brief answer. 1.13. What is the ratio of the Female students (as % of total students) of World in 1993 to that in 2000?
Keep it short and to the point. 0.97. What is the ratio of the Female students (as % of total students) of Austria in 1993 to that in 2000?
Your answer should be very brief. 0.99. What is the ratio of the Female students (as % of total students) of Kuwait in 1993 to that in 2000?
Provide a short and direct response. 0.99. What is the ratio of the Female students (as % of total students) in World in 1993 to that in 2005?
Your response must be concise. 0.95. What is the ratio of the Female students (as % of total students) in Austria in 1993 to that in 2005?
Provide a short and direct response. 0.99. What is the ratio of the Female students (as % of total students) in Equatorial Guinea in 1993 to that in 2005?
Offer a terse response. 0.73. What is the ratio of the Female students (as % of total students) of Kuwait in 1993 to that in 2005?
Provide a succinct answer. 0.97. What is the ratio of the Female students (as % of total students) in World in 1994 to that in 1999?
Offer a terse response. 0.97. What is the ratio of the Female students (as % of total students) of Equatorial Guinea in 1994 to that in 1999?
Provide a succinct answer. 1.28. What is the ratio of the Female students (as % of total students) of World in 1994 to that in 2000?
Keep it short and to the point. 0.97. What is the ratio of the Female students (as % of total students) in Austria in 1994 to that in 2000?
Your answer should be very brief. 0.99. What is the ratio of the Female students (as % of total students) in Equatorial Guinea in 1994 to that in 2000?
Your answer should be very brief. 1.13. What is the ratio of the Female students (as % of total students) of World in 1994 to that in 2005?
Your response must be concise. 0.96. What is the ratio of the Female students (as % of total students) in Equatorial Guinea in 1994 to that in 2005?
Give a very brief answer. 0.83. What is the ratio of the Female students (as % of total students) of Kuwait in 1994 to that in 2005?
Provide a succinct answer. 0.97. What is the ratio of the Female students (as % of total students) in World in 1999 to that in 2000?
Your response must be concise. 1. What is the ratio of the Female students (as % of total students) in Austria in 1999 to that in 2000?
Provide a succinct answer. 1. What is the ratio of the Female students (as % of total students) of Equatorial Guinea in 1999 to that in 2000?
Ensure brevity in your answer.  0.88. What is the ratio of the Female students (as % of total students) in Kuwait in 1999 to that in 2000?
Offer a very short reply. 0.99. What is the ratio of the Female students (as % of total students) in World in 1999 to that in 2005?
Keep it short and to the point. 0.99. What is the ratio of the Female students (as % of total students) of Austria in 1999 to that in 2005?
Provide a succinct answer. 1. What is the ratio of the Female students (as % of total students) in Equatorial Guinea in 1999 to that in 2005?
Give a very brief answer. 0.65. What is the ratio of the Female students (as % of total students) of World in 2000 to that in 2005?
Make the answer very short. 0.99. What is the ratio of the Female students (as % of total students) in Equatorial Guinea in 2000 to that in 2005?
Your answer should be compact. 0.73. What is the ratio of the Female students (as % of total students) of Kuwait in 2000 to that in 2005?
Provide a short and direct response. 0.98. What is the difference between the highest and the second highest Female students (as % of total students) of World?
Your answer should be compact. 0.62. What is the difference between the highest and the second highest Female students (as % of total students) in Austria?
Provide a short and direct response. 0.12. What is the difference between the highest and the second highest Female students (as % of total students) of Equatorial Guinea?
Give a very brief answer. 7.16. What is the difference between the highest and the second highest Female students (as % of total students) of Kuwait?
Your answer should be compact. 1.13. What is the difference between the highest and the lowest Female students (as % of total students) in World?
Ensure brevity in your answer.  5.1. What is the difference between the highest and the lowest Female students (as % of total students) in Austria?
Your response must be concise. 1.66. What is the difference between the highest and the lowest Female students (as % of total students) of Equatorial Guinea?
Keep it short and to the point. 25.1. What is the difference between the highest and the lowest Female students (as % of total students) in Kuwait?
Offer a terse response. 7.97. 